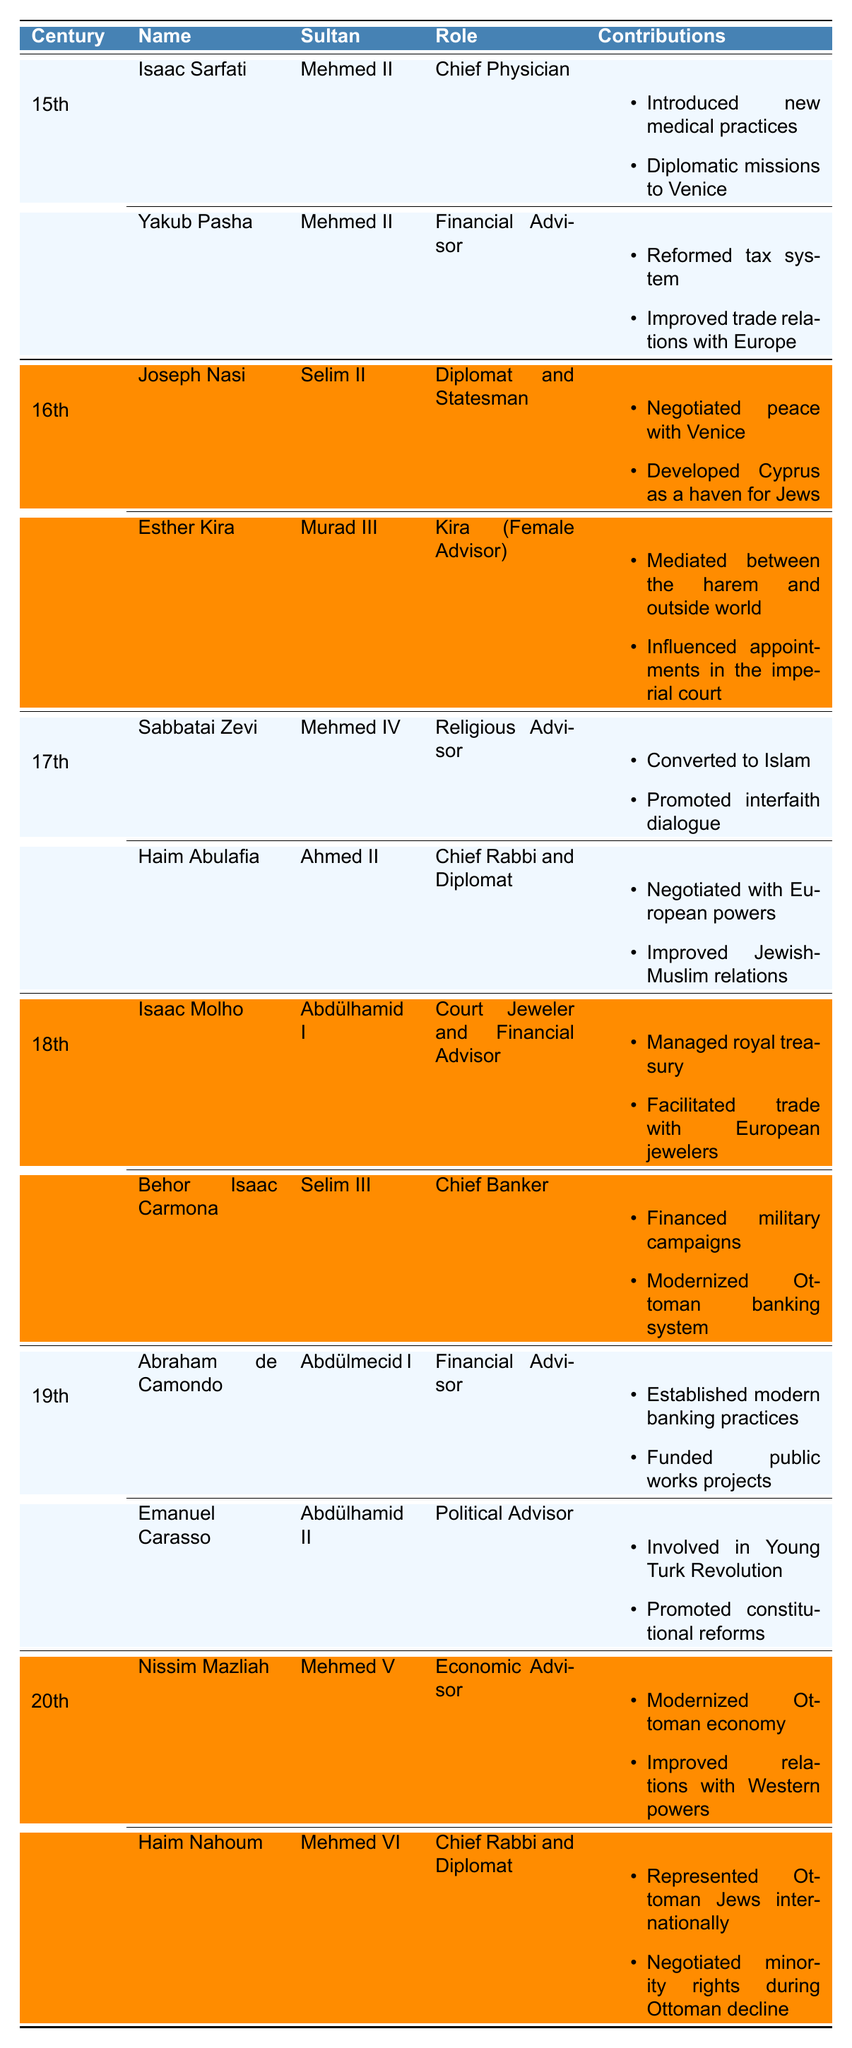What role did Isaac Sarfati serve under Mehmed II? According to the table, Isaac Sarfati served as the Chief Physician under Sultan Mehmed II during the 15th century.
Answer: Chief Physician How many Jewish advisors are listed for the 18th century? The table shows two Jewish advisors listed for the 18th century: Isaac Molho and Behor Isaac Carmona.
Answer: 2 Which advisor contributed to the development of Cyprus as a haven for Jews? Joseph Nasi is noted in the table for developing Cyprus as a haven for Jews during the 16th century under Sultan Selim II.
Answer: Joseph Nasi Did any advisor from the 19th century focus on political reforms? Yes, the table indicates that Emanuel Carasso was involved in promoting constitutional reforms during the 19th century for Sultan Abdülhamid II.
Answer: Yes Who served as Chief Rabbi and also acted as a diplomat? The table identifies Haim Nahoum as both Chief Rabbi and Diplomat under Sultan Mehmed VI in the 20th century.
Answer: Haim Nahoum Which advisor is associated with negotiations during the Ottoman decline? Haim Nahoum is noted for negotiating minority rights during the decline of the Ottoman Empire in the table.
Answer: Haim Nahoum In which century did Esther Kira serve, and what was her role? Esther Kira served in the 16th century as a Kira (Female Advisor) under Sultan Murad III, as per the table.
Answer: 16th century, Kira Are there more advisors listed in the 17th century than the 19th century? The table lists two advisors for both the 17th and 19th centuries, showing that they are equal in number.
Answer: No What was one of the contributions made by Abraham de Camondo? The table states that Abraham de Camondo established modern banking practices among other contributions during the 19th century.
Answer: Established modern banking practices Identify any advisor who converted to Islam. According to the table, Sabbatai Zevi converted to Islam while serving as a Religious Advisor under Sultan Mehmed IV in the 17th century.
Answer: Sabbatai Zevi Which advisor's contributions included negotiating peace with Venice? Joseph Nasi's contributions included negotiating peace with Venice during his term under Sultan Selim II in the 16th century.
Answer: Joseph Nasi What was the role of Behor Isaac Carmona? Behor Isaac Carmona served as the Chief Banker during the 18th century under Sultan Selim III, as noted in the table.
Answer: Chief Banker What contributions did Nissim Mazliah make as an economic advisor? Nissim Mazliah contributed by modernizing the Ottoman economy and improving relations with Western powers during the 20th century.
Answer: Modernized Ottoman economy, improved relations Are all advisors listed for the 15th century associated with Sultan Mehmed II? Yes, both advisors listed for the 15th century, Isaac Sarfati and Yakub Pasha, are associated with Sultan Mehmed II according to the table.
Answer: Yes What distinguishes Esther Kira from other advisors? Esther Kira is distinguished as a Kira (Female Advisor), which is unique among the male-dominated advisors listed in the table.
Answer: Female Advisor 